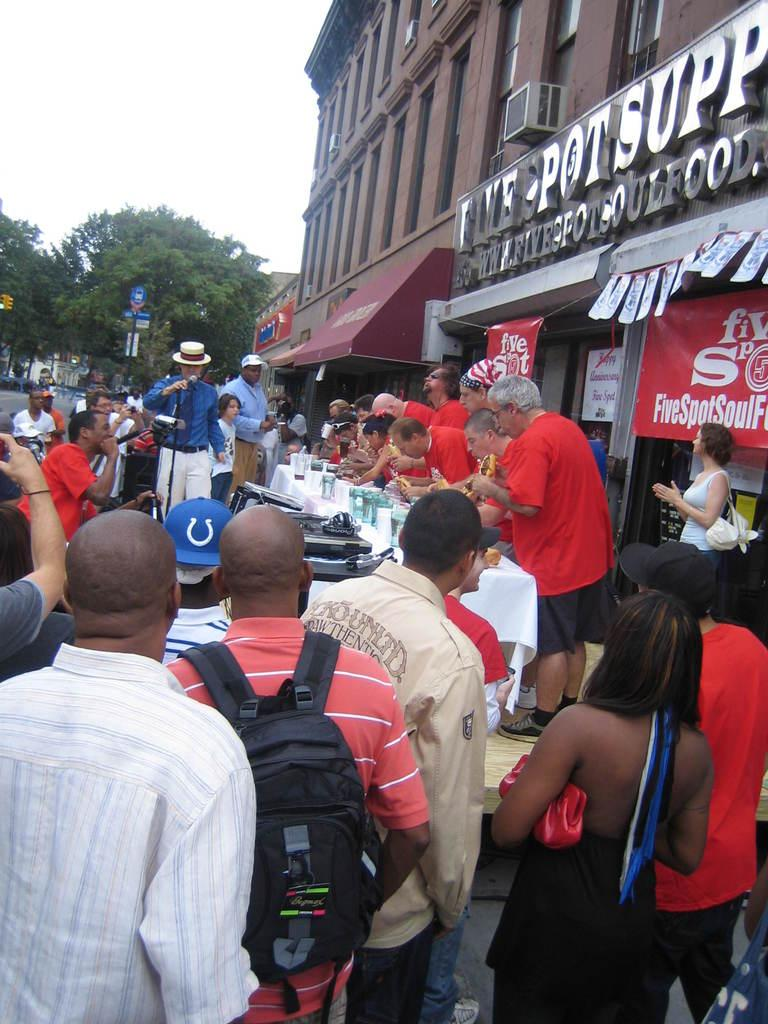Who or what is present in the image? There are people in the image. What object is placed on a stand in the image? There is a microphone placed on a stand in the image. What can be seen in the background of the image? There are buildings, boards, trees, and the sky visible in the background of the image. What type of canvas is being smashed by the people in the image? There is no canvas present in the image, nor are the people smashing anything. 